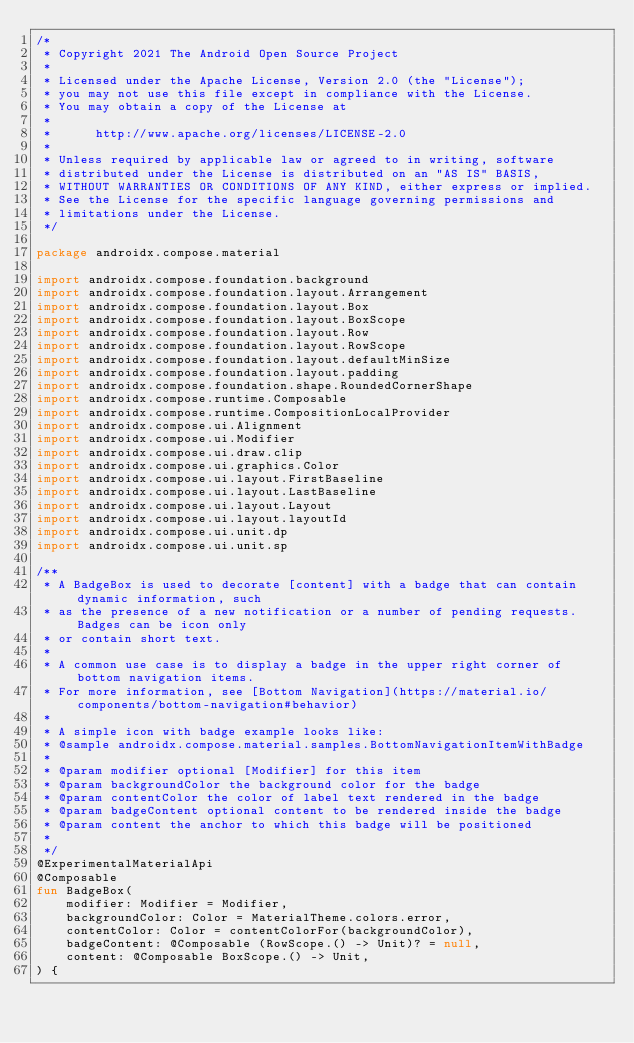<code> <loc_0><loc_0><loc_500><loc_500><_Kotlin_>/*
 * Copyright 2021 The Android Open Source Project
 *
 * Licensed under the Apache License, Version 2.0 (the "License");
 * you may not use this file except in compliance with the License.
 * You may obtain a copy of the License at
 *
 *      http://www.apache.org/licenses/LICENSE-2.0
 *
 * Unless required by applicable law or agreed to in writing, software
 * distributed under the License is distributed on an "AS IS" BASIS,
 * WITHOUT WARRANTIES OR CONDITIONS OF ANY KIND, either express or implied.
 * See the License for the specific language governing permissions and
 * limitations under the License.
 */

package androidx.compose.material

import androidx.compose.foundation.background
import androidx.compose.foundation.layout.Arrangement
import androidx.compose.foundation.layout.Box
import androidx.compose.foundation.layout.BoxScope
import androidx.compose.foundation.layout.Row
import androidx.compose.foundation.layout.RowScope
import androidx.compose.foundation.layout.defaultMinSize
import androidx.compose.foundation.layout.padding
import androidx.compose.foundation.shape.RoundedCornerShape
import androidx.compose.runtime.Composable
import androidx.compose.runtime.CompositionLocalProvider
import androidx.compose.ui.Alignment
import androidx.compose.ui.Modifier
import androidx.compose.ui.draw.clip
import androidx.compose.ui.graphics.Color
import androidx.compose.ui.layout.FirstBaseline
import androidx.compose.ui.layout.LastBaseline
import androidx.compose.ui.layout.Layout
import androidx.compose.ui.layout.layoutId
import androidx.compose.ui.unit.dp
import androidx.compose.ui.unit.sp

/**
 * A BadgeBox is used to decorate [content] with a badge that can contain dynamic information, such
 * as the presence of a new notification or a number of pending requests. Badges can be icon only
 * or contain short text.
 *
 * A common use case is to display a badge in the upper right corner of bottom navigation items.
 * For more information, see [Bottom Navigation](https://material.io/components/bottom-navigation#behavior)
 *
 * A simple icon with badge example looks like:
 * @sample androidx.compose.material.samples.BottomNavigationItemWithBadge
 *
 * @param modifier optional [Modifier] for this item
 * @param backgroundColor the background color for the badge
 * @param contentColor the color of label text rendered in the badge
 * @param badgeContent optional content to be rendered inside the badge
 * @param content the anchor to which this badge will be positioned
 *
 */
@ExperimentalMaterialApi
@Composable
fun BadgeBox(
    modifier: Modifier = Modifier,
    backgroundColor: Color = MaterialTheme.colors.error,
    contentColor: Color = contentColorFor(backgroundColor),
    badgeContent: @Composable (RowScope.() -> Unit)? = null,
    content: @Composable BoxScope.() -> Unit,
) {</code> 